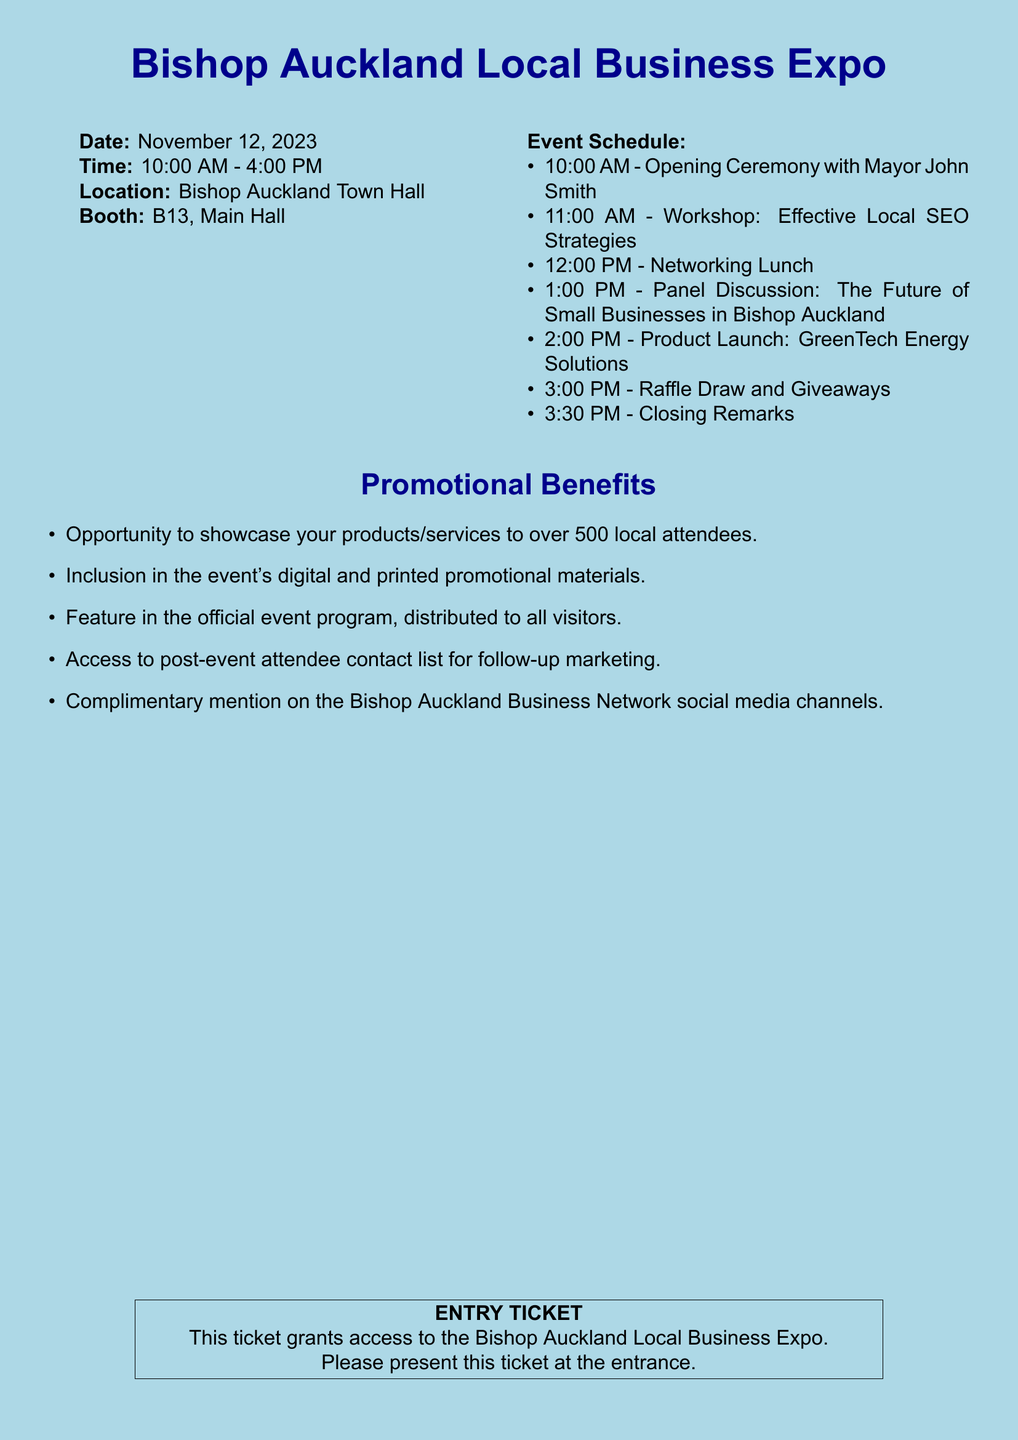What is the event date? The event date is mentioned clearly at the beginning of the document under the details section.
Answer: November 12, 2023 What time does the expo start? The starting time of the expo is stated in the document as part of the event details.
Answer: 10:00 AM Where is the expo taking place? The location is specified in the initial details section of the document.
Answer: Bishop Auckland Town Hall What is the booth number? The booth number is part of the logistical details provided in the document.
Answer: B13, Main Hall Who is the keynote speaker at the opening ceremony? The name of the keynote speaker is noted in the event schedule section of the document.
Answer: Mayor John Smith What time is the networking lunch scheduled? The time for the networking lunch is included in the event schedule.
Answer: 12:00 PM What is one promotional benefit listed? The benefits section mentions several promotional advantages; one example can be any listed.
Answer: Opportunity to showcase your products/services to over 500 local attendees How many local attendees are expected? The number of expected attendees is mentioned in the promotional benefits section.
Answer: Over 500 What closes the event? The final closing event is summarized in the document schedule.
Answer: Closing Remarks 